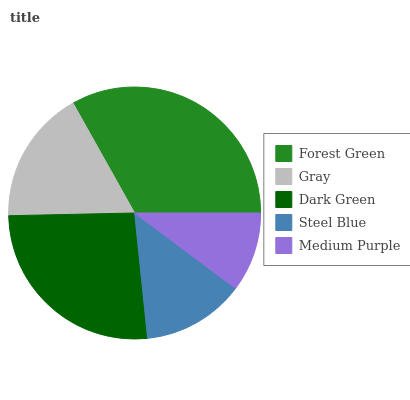Is Medium Purple the minimum?
Answer yes or no. Yes. Is Forest Green the maximum?
Answer yes or no. Yes. Is Gray the minimum?
Answer yes or no. No. Is Gray the maximum?
Answer yes or no. No. Is Forest Green greater than Gray?
Answer yes or no. Yes. Is Gray less than Forest Green?
Answer yes or no. Yes. Is Gray greater than Forest Green?
Answer yes or no. No. Is Forest Green less than Gray?
Answer yes or no. No. Is Gray the high median?
Answer yes or no. Yes. Is Gray the low median?
Answer yes or no. Yes. Is Dark Green the high median?
Answer yes or no. No. Is Medium Purple the low median?
Answer yes or no. No. 